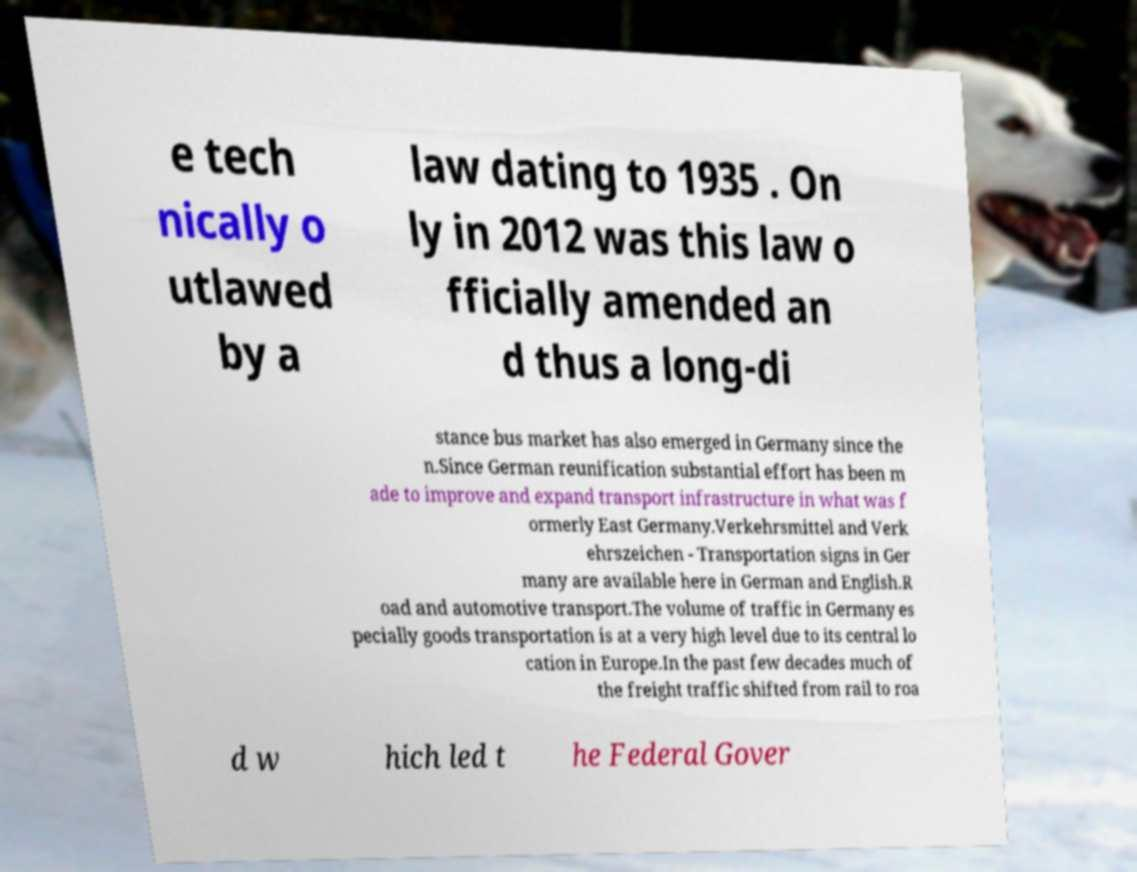Can you read and provide the text displayed in the image?This photo seems to have some interesting text. Can you extract and type it out for me? e tech nically o utlawed by a law dating to 1935 . On ly in 2012 was this law o fficially amended an d thus a long-di stance bus market has also emerged in Germany since the n.Since German reunification substantial effort has been m ade to improve and expand transport infrastructure in what was f ormerly East Germany.Verkehrsmittel and Verk ehrszeichen - Transportation signs in Ger many are available here in German and English.R oad and automotive transport.The volume of traffic in Germany es pecially goods transportation is at a very high level due to its central lo cation in Europe.In the past few decades much of the freight traffic shifted from rail to roa d w hich led t he Federal Gover 